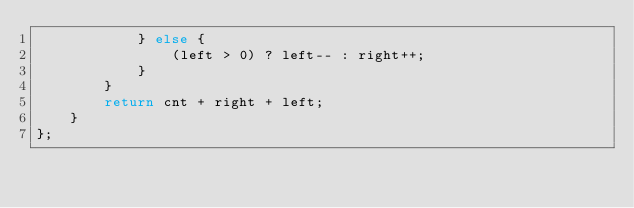Convert code to text. <code><loc_0><loc_0><loc_500><loc_500><_C++_>			} else {
				(left > 0) ? left-- : right++;
			}
		}
		return cnt + right + left;
	}
};
</code> 